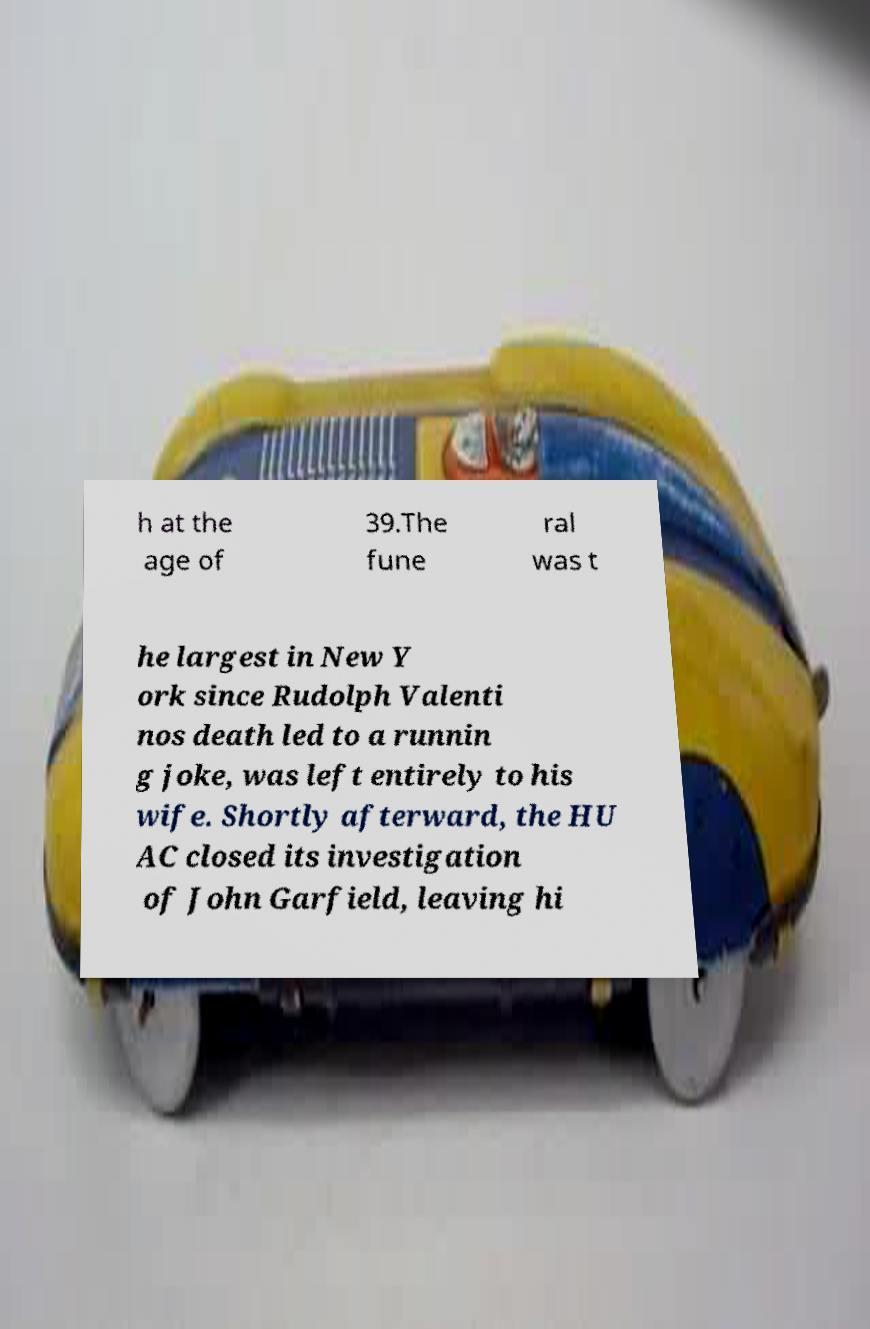Can you accurately transcribe the text from the provided image for me? h at the age of 39.The fune ral was t he largest in New Y ork since Rudolph Valenti nos death led to a runnin g joke, was left entirely to his wife. Shortly afterward, the HU AC closed its investigation of John Garfield, leaving hi 